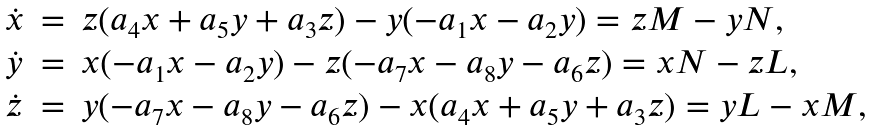Convert formula to latex. <formula><loc_0><loc_0><loc_500><loc_500>\begin{array} { l c l } \dot { x } & = & z ( a _ { 4 } x + a _ { 5 } y + a _ { 3 } z ) - y ( - a _ { 1 } x - a _ { 2 } y ) = z M - y N , \\ \dot { y } & = & x ( - a _ { 1 } x - a _ { 2 } y ) - z ( - a _ { 7 } x - a _ { 8 } y - a _ { 6 } z ) = x N - z L , \\ \dot { z } & = & y ( - a _ { 7 } x - a _ { 8 } y - a _ { 6 } z ) - x ( a _ { 4 } x + a _ { 5 } y + a _ { 3 } z ) = y L - x M , \end{array}</formula> 